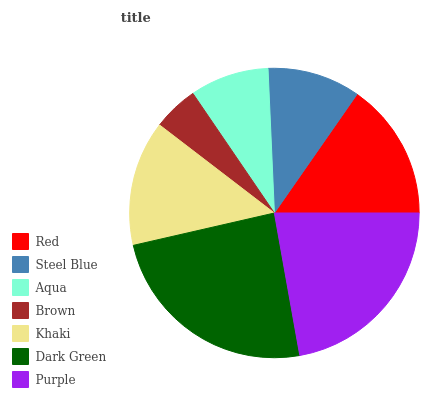Is Brown the minimum?
Answer yes or no. Yes. Is Dark Green the maximum?
Answer yes or no. Yes. Is Steel Blue the minimum?
Answer yes or no. No. Is Steel Blue the maximum?
Answer yes or no. No. Is Red greater than Steel Blue?
Answer yes or no. Yes. Is Steel Blue less than Red?
Answer yes or no. Yes. Is Steel Blue greater than Red?
Answer yes or no. No. Is Red less than Steel Blue?
Answer yes or no. No. Is Khaki the high median?
Answer yes or no. Yes. Is Khaki the low median?
Answer yes or no. Yes. Is Purple the high median?
Answer yes or no. No. Is Aqua the low median?
Answer yes or no. No. 